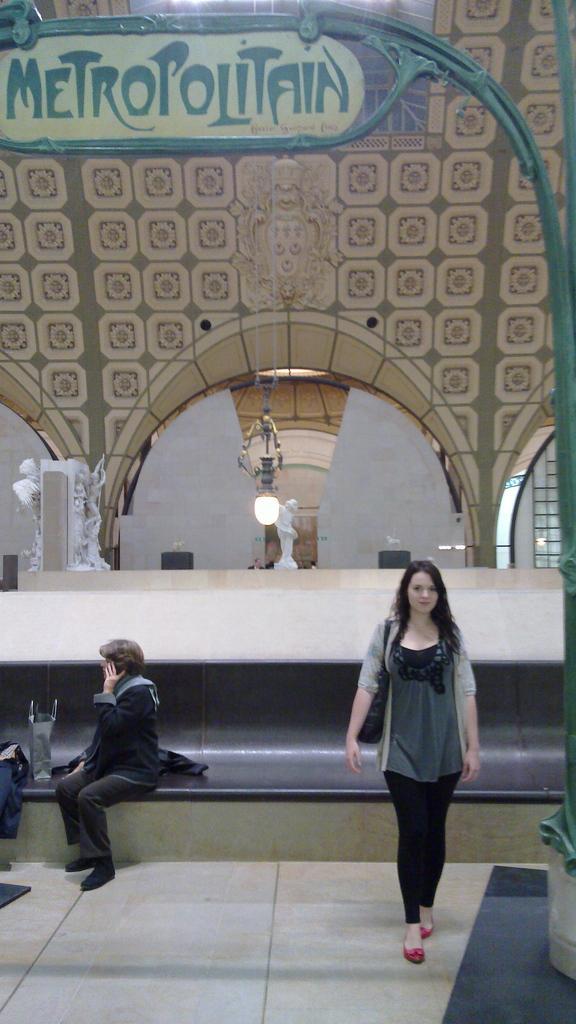Can you describe this image briefly? In this image we can see a lady walking. On the left there is a person sitting on the bench. There is a bag and we can see clothes placed on the bench. In the background there is a counter top and we can see sculptures on the counter top. There is a light. At the top we can see a board. 